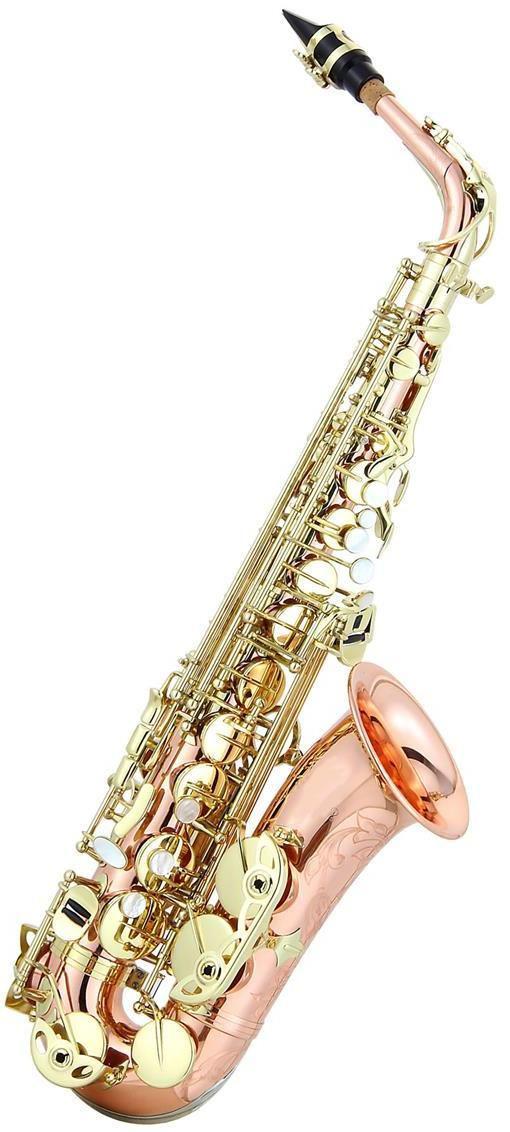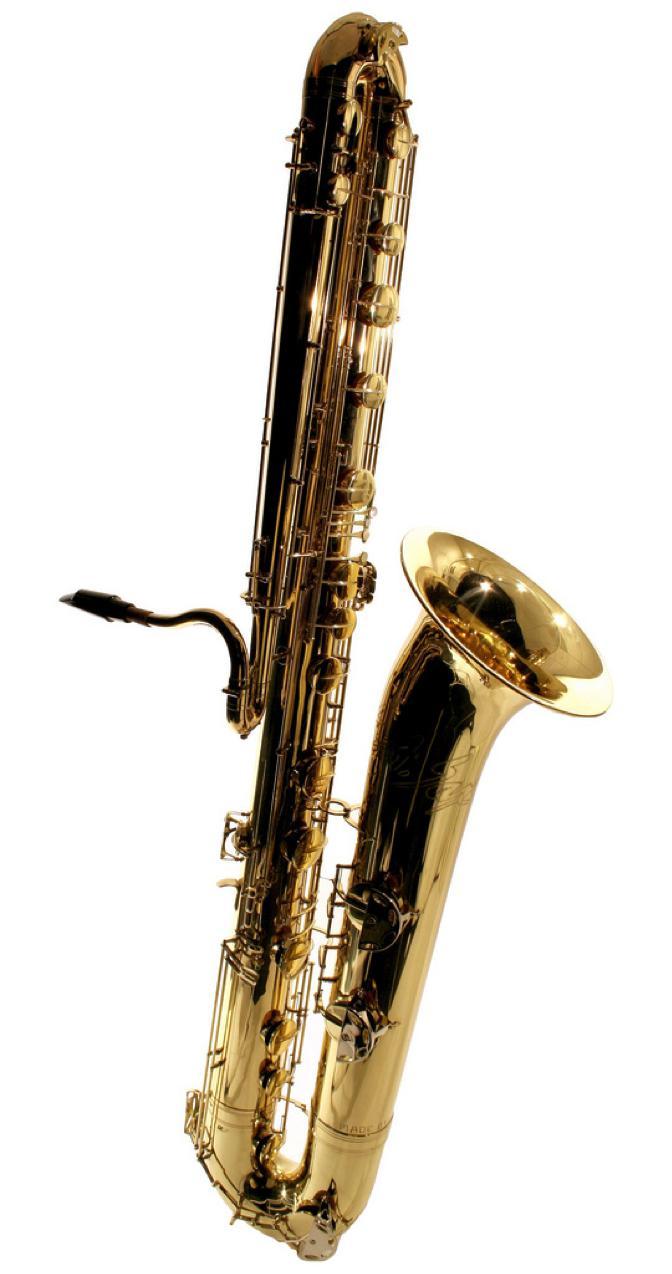The first image is the image on the left, the second image is the image on the right. Examine the images to the left and right. Is the description "Each image has an instrument where the body is not gold, though all the buttons are." accurate? Answer yes or no. No. The first image is the image on the left, the second image is the image on the right. Considering the images on both sides, is "The saxophone on the left is bright metallic blue with gold buttons and is posed with the bell facing rightward." valid? Answer yes or no. No. 